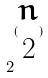Convert formula to latex. <formula><loc_0><loc_0><loc_500><loc_500>2 ^ { ( \begin{matrix} n \\ 2 \end{matrix} ) }</formula> 